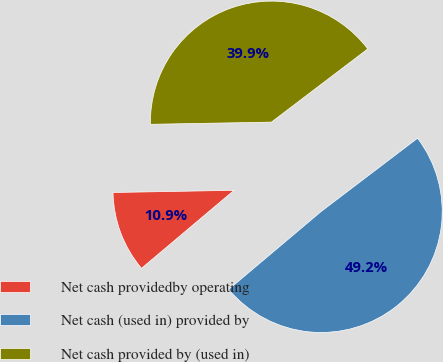Convert chart to OTSL. <chart><loc_0><loc_0><loc_500><loc_500><pie_chart><fcel>Net cash providedby operating<fcel>Net cash (used in) provided by<fcel>Net cash provided by (used in)<nl><fcel>10.86%<fcel>49.19%<fcel>39.94%<nl></chart> 